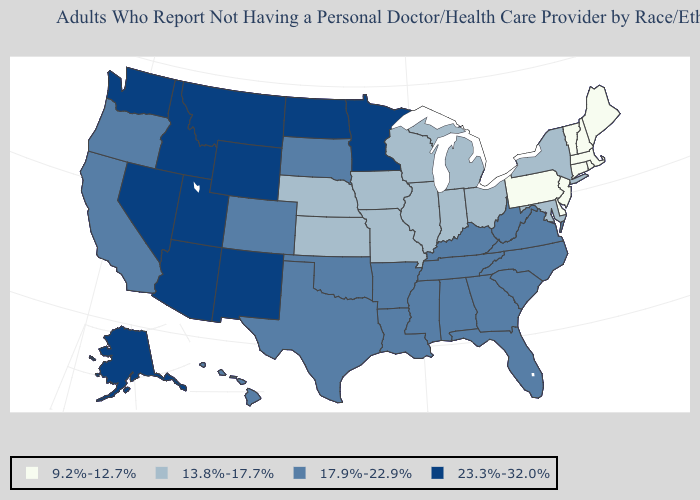Among the states that border Maryland , does West Virginia have the highest value?
Short answer required. Yes. Name the states that have a value in the range 13.8%-17.7%?
Be succinct. Illinois, Indiana, Iowa, Kansas, Maryland, Michigan, Missouri, Nebraska, New York, Ohio, Wisconsin. Does Arizona have a higher value than North Dakota?
Concise answer only. No. Does the map have missing data?
Keep it brief. No. Name the states that have a value in the range 13.8%-17.7%?
Answer briefly. Illinois, Indiana, Iowa, Kansas, Maryland, Michigan, Missouri, Nebraska, New York, Ohio, Wisconsin. Does the first symbol in the legend represent the smallest category?
Write a very short answer. Yes. Name the states that have a value in the range 17.9%-22.9%?
Be succinct. Alabama, Arkansas, California, Colorado, Florida, Georgia, Hawaii, Kentucky, Louisiana, Mississippi, North Carolina, Oklahoma, Oregon, South Carolina, South Dakota, Tennessee, Texas, Virginia, West Virginia. Name the states that have a value in the range 17.9%-22.9%?
Short answer required. Alabama, Arkansas, California, Colorado, Florida, Georgia, Hawaii, Kentucky, Louisiana, Mississippi, North Carolina, Oklahoma, Oregon, South Carolina, South Dakota, Tennessee, Texas, Virginia, West Virginia. Name the states that have a value in the range 9.2%-12.7%?
Write a very short answer. Connecticut, Delaware, Maine, Massachusetts, New Hampshire, New Jersey, Pennsylvania, Rhode Island, Vermont. Name the states that have a value in the range 17.9%-22.9%?
Write a very short answer. Alabama, Arkansas, California, Colorado, Florida, Georgia, Hawaii, Kentucky, Louisiana, Mississippi, North Carolina, Oklahoma, Oregon, South Carolina, South Dakota, Tennessee, Texas, Virginia, West Virginia. What is the value of Iowa?
Concise answer only. 13.8%-17.7%. What is the highest value in the Northeast ?
Keep it brief. 13.8%-17.7%. Among the states that border Connecticut , does Rhode Island have the highest value?
Be succinct. No. Does Texas have the highest value in the USA?
Answer briefly. No. 